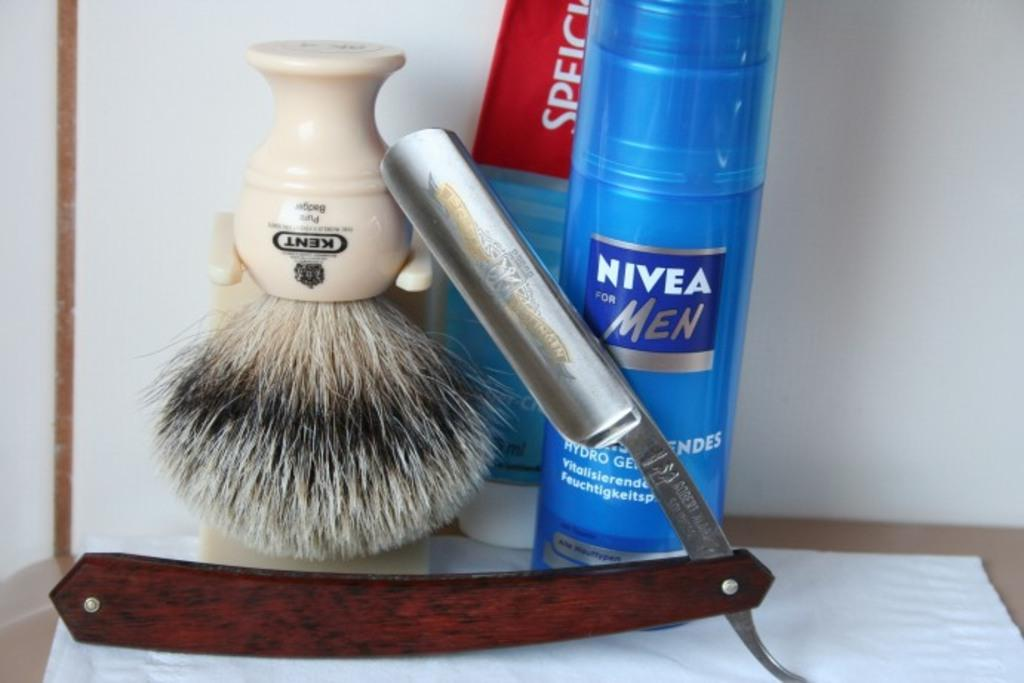<image>
Provide a brief description of the given image. A razor blade sits amongst shaving equipment including NIVEA FOR MEN. 